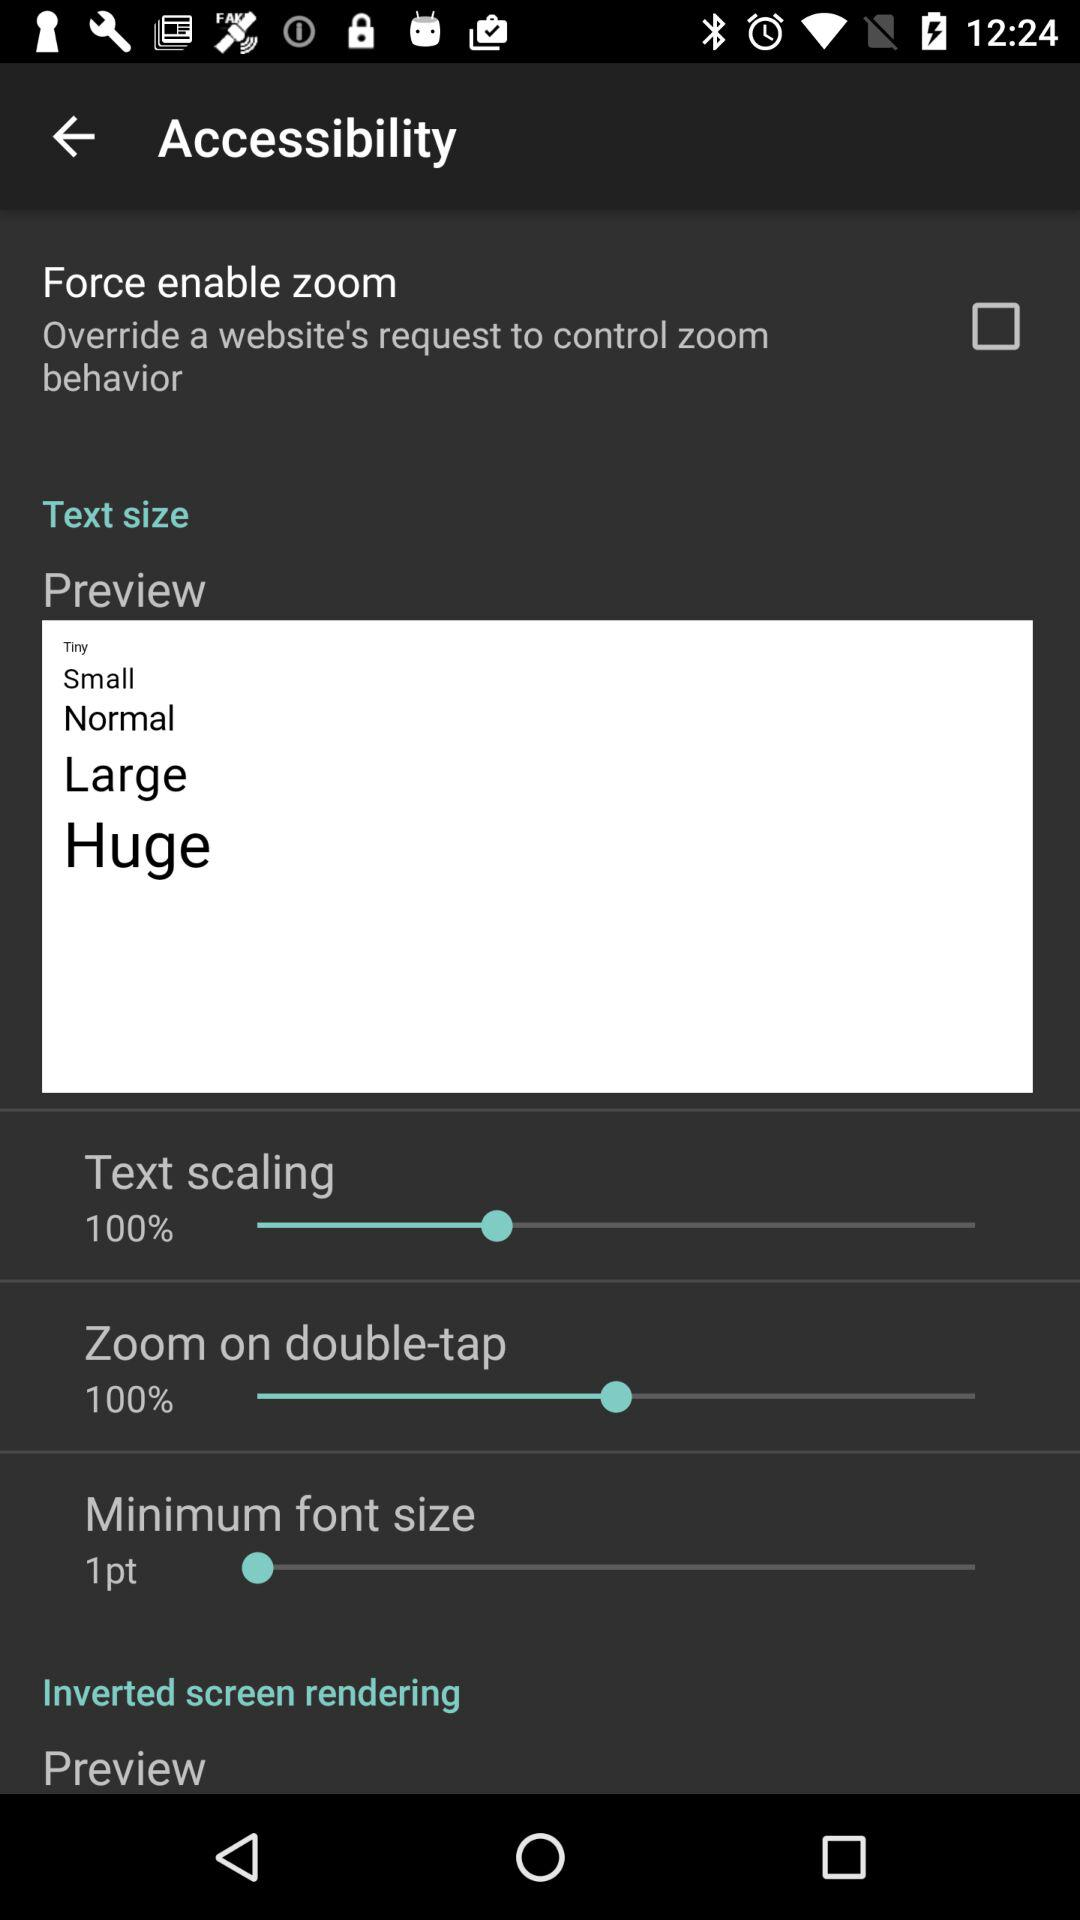What is the selected "Text scaling"? The selected "Text scaling" is 100%. 